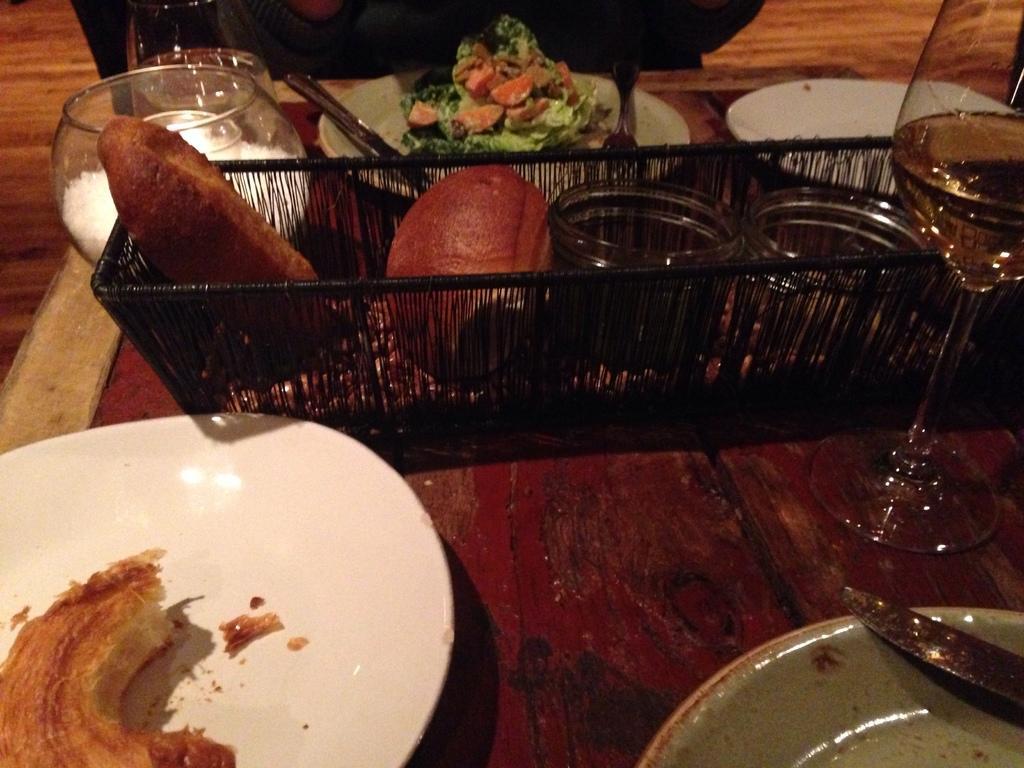How would you summarize this image in a sentence or two? In this image I can see plates,food items,spoons,jars,glass on the brown table. They are in different color. 